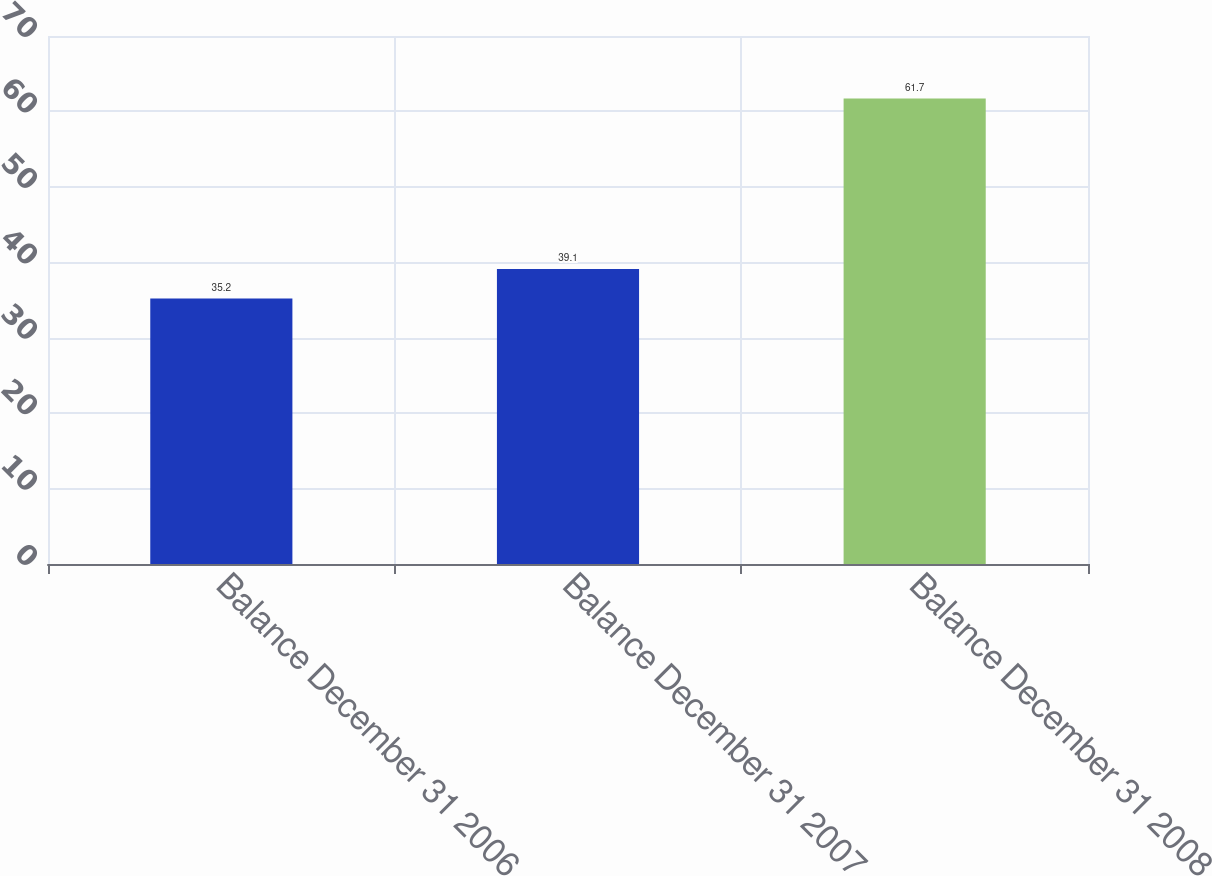Convert chart. <chart><loc_0><loc_0><loc_500><loc_500><bar_chart><fcel>Balance December 31 2006<fcel>Balance December 31 2007<fcel>Balance December 31 2008<nl><fcel>35.2<fcel>39.1<fcel>61.7<nl></chart> 